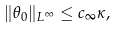Convert formula to latex. <formula><loc_0><loc_0><loc_500><loc_500>\| \theta _ { 0 } \| _ { L ^ { \infty } } \leq c _ { \infty } \kappa ,</formula> 